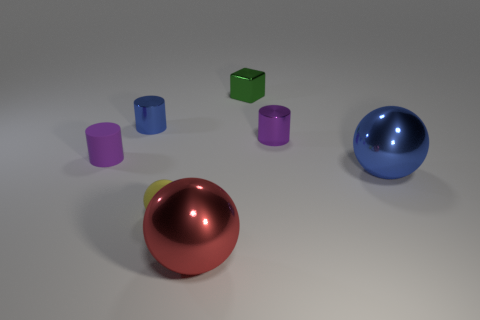How many objects are spheres that are to the left of the big red metal sphere or tiny cylinders behind the purple metal thing?
Your response must be concise. 2. There is a yellow rubber sphere; are there any tiny purple things in front of it?
Your response must be concise. No. How many objects are purple objects right of the rubber cylinder or small blue shiny objects?
Your answer should be very brief. 2. What number of yellow objects are small matte things or tiny matte cylinders?
Offer a very short reply. 1. What number of other things are there of the same color as the small ball?
Offer a terse response. 0. Is the number of tiny matte objects that are on the right side of the blue cylinder less than the number of big blue shiny things?
Give a very brief answer. No. There is a shiny cylinder on the right side of the thing in front of the tiny object in front of the big blue metallic ball; what is its color?
Give a very brief answer. Purple. There is a purple rubber object that is the same shape as the small purple metallic object; what size is it?
Provide a short and direct response. Small. Are there fewer large blue balls behind the tiny purple rubber cylinder than purple shiny things behind the tiny yellow thing?
Give a very brief answer. Yes. The metallic object that is to the left of the tiny green metallic block and in front of the small blue metal thing has what shape?
Give a very brief answer. Sphere. 